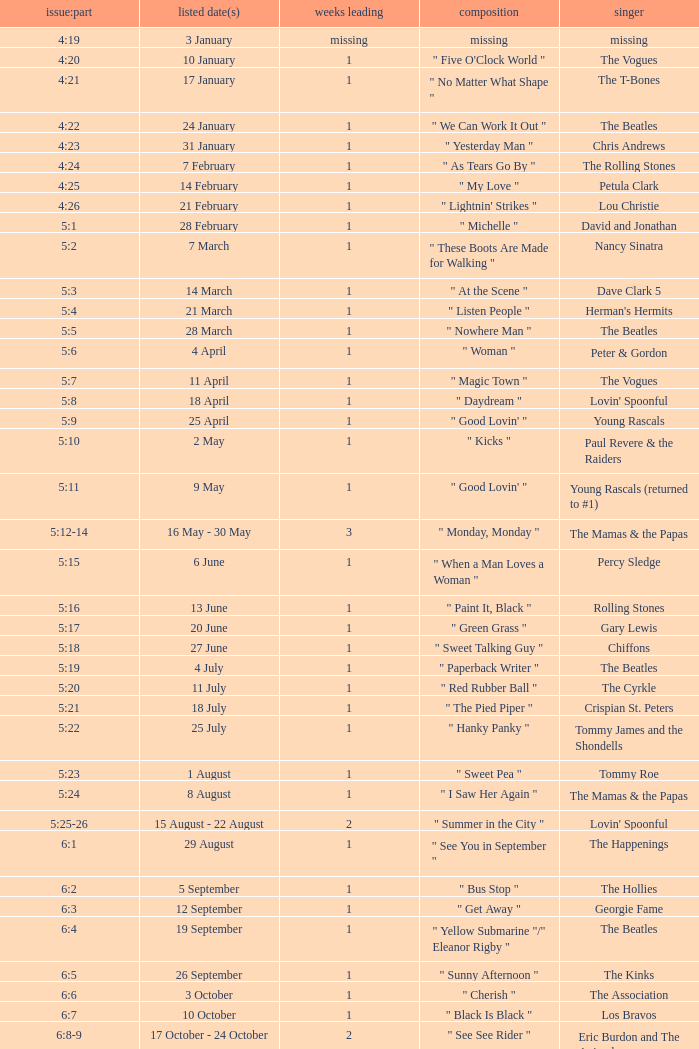Volume:Issue of 5:16 has what song listed? " Paint It, Black ". 